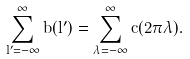Convert formula to latex. <formula><loc_0><loc_0><loc_500><loc_500>\sum _ { l ^ { \prime } = - \infty } ^ { \infty } b ( l ^ { \prime } ) = \sum _ { \lambda = - \infty } ^ { \infty } c ( 2 \pi \lambda ) .</formula> 